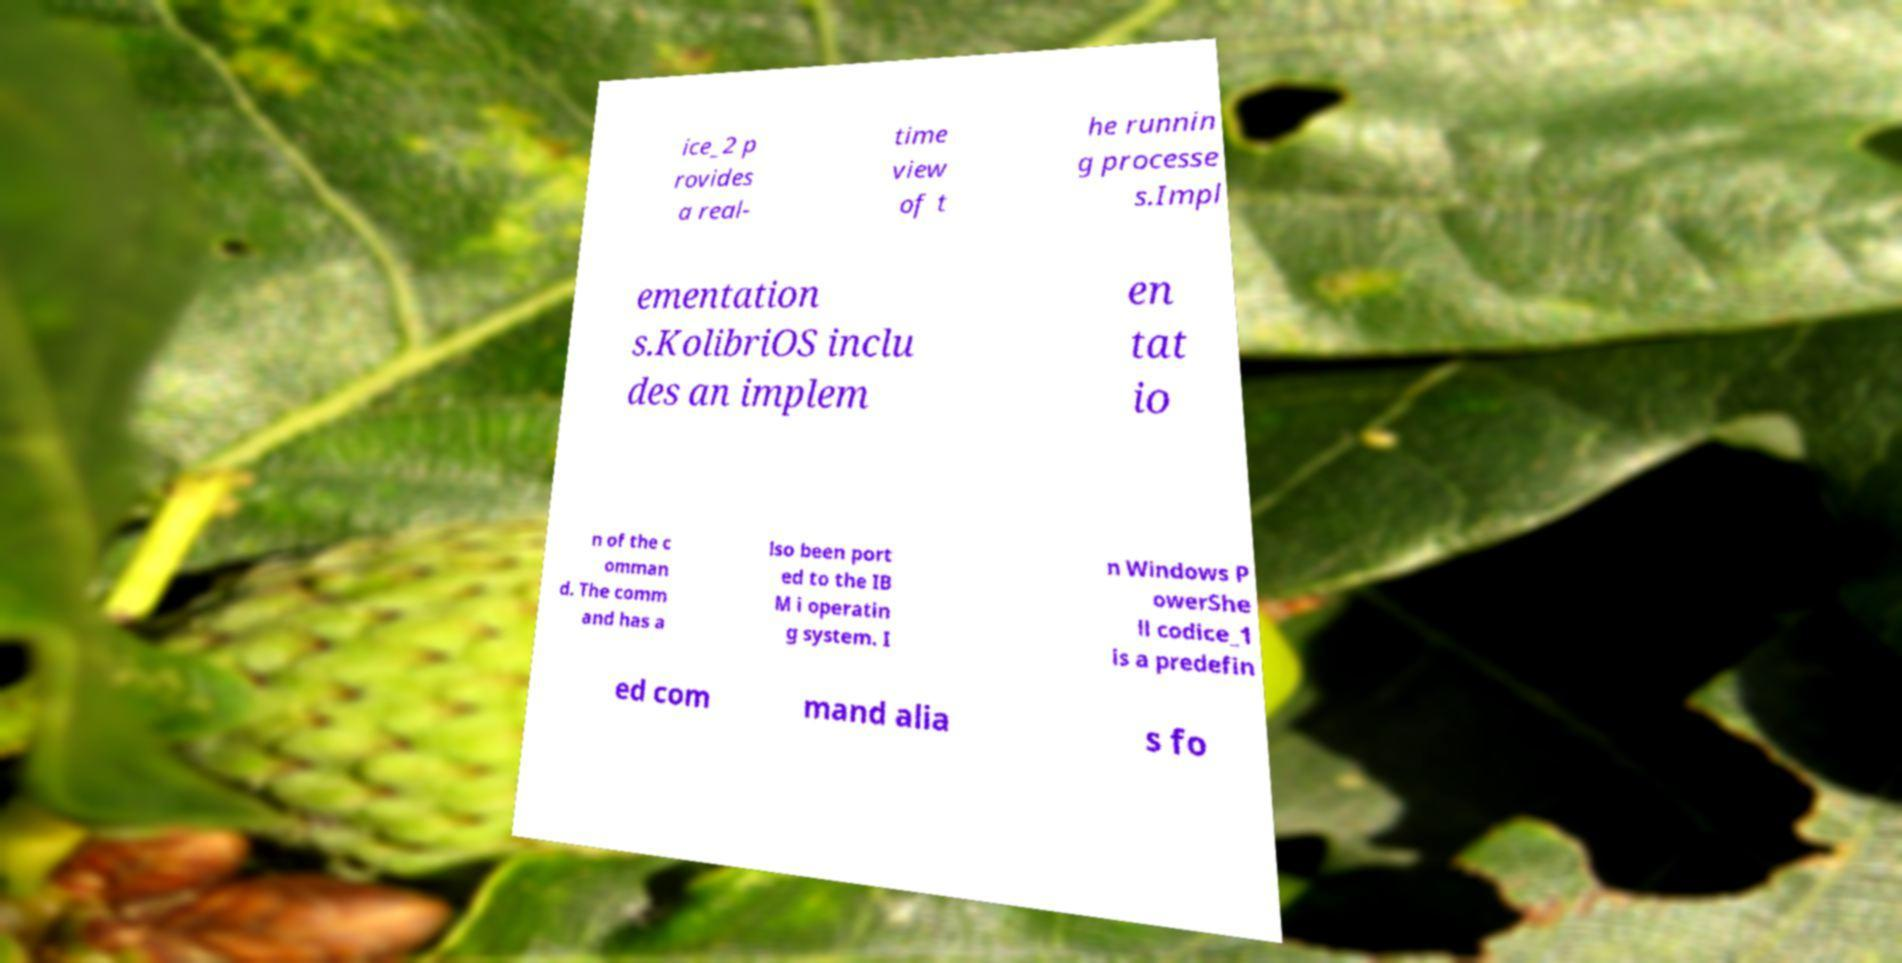I need the written content from this picture converted into text. Can you do that? ice_2 p rovides a real- time view of t he runnin g processe s.Impl ementation s.KolibriOS inclu des an implem en tat io n of the c omman d. The comm and has a lso been port ed to the IB M i operatin g system. I n Windows P owerShe ll codice_1 is a predefin ed com mand alia s fo 